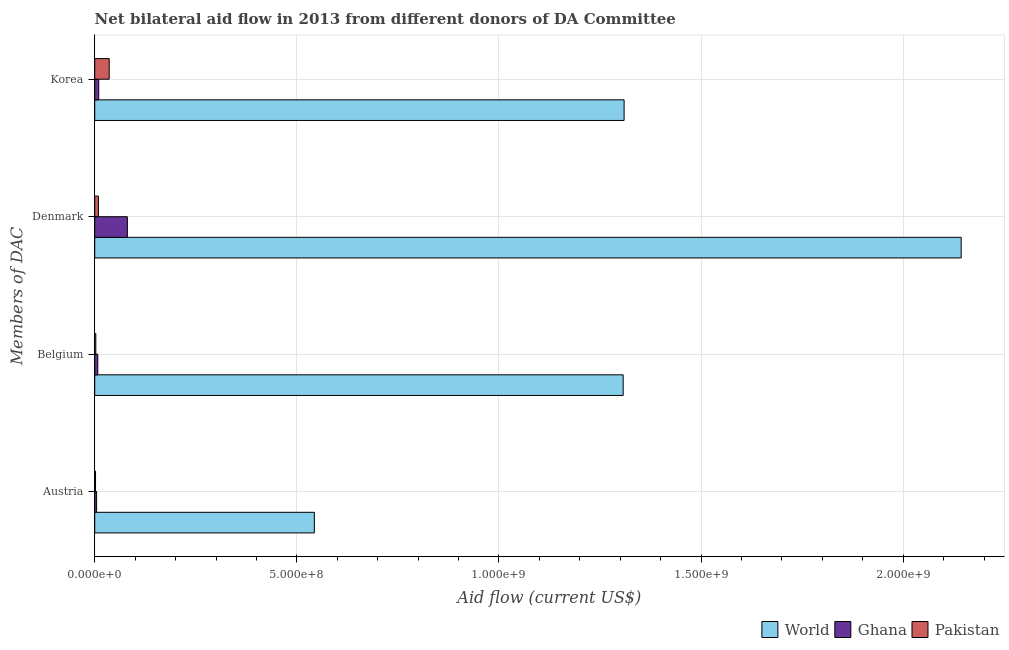Are the number of bars per tick equal to the number of legend labels?
Make the answer very short. Yes. Are the number of bars on each tick of the Y-axis equal?
Keep it short and to the point. Yes. How many bars are there on the 1st tick from the top?
Give a very brief answer. 3. What is the label of the 2nd group of bars from the top?
Your answer should be very brief. Denmark. What is the amount of aid given by belgium in Ghana?
Offer a very short reply. 7.56e+06. Across all countries, what is the maximum amount of aid given by denmark?
Offer a very short reply. 2.14e+09. Across all countries, what is the minimum amount of aid given by austria?
Offer a very short reply. 1.99e+06. What is the total amount of aid given by austria in the graph?
Provide a short and direct response. 5.50e+08. What is the difference between the amount of aid given by austria in Pakistan and that in World?
Offer a very short reply. -5.41e+08. What is the difference between the amount of aid given by belgium in World and the amount of aid given by korea in Pakistan?
Ensure brevity in your answer.  1.27e+09. What is the average amount of aid given by austria per country?
Your answer should be very brief. 1.83e+08. What is the difference between the amount of aid given by korea and amount of aid given by belgium in Ghana?
Ensure brevity in your answer.  2.29e+06. In how many countries, is the amount of aid given by austria greater than 1200000000 US$?
Make the answer very short. 0. What is the ratio of the amount of aid given by korea in World to that in Pakistan?
Offer a very short reply. 36.53. What is the difference between the highest and the second highest amount of aid given by belgium?
Ensure brevity in your answer.  1.30e+09. What is the difference between the highest and the lowest amount of aid given by denmark?
Give a very brief answer. 2.13e+09. Is it the case that in every country, the sum of the amount of aid given by austria and amount of aid given by belgium is greater than the amount of aid given by denmark?
Give a very brief answer. No. How many countries are there in the graph?
Provide a short and direct response. 3. Does the graph contain grids?
Offer a very short reply. Yes. Where does the legend appear in the graph?
Offer a very short reply. Bottom right. What is the title of the graph?
Make the answer very short. Net bilateral aid flow in 2013 from different donors of DA Committee. What is the label or title of the Y-axis?
Give a very brief answer. Members of DAC. What is the Aid flow (current US$) of World in Austria?
Your answer should be very brief. 5.43e+08. What is the Aid flow (current US$) in Ghana in Austria?
Give a very brief answer. 4.59e+06. What is the Aid flow (current US$) of Pakistan in Austria?
Provide a short and direct response. 1.99e+06. What is the Aid flow (current US$) of World in Belgium?
Offer a terse response. 1.31e+09. What is the Aid flow (current US$) of Ghana in Belgium?
Offer a terse response. 7.56e+06. What is the Aid flow (current US$) of Pakistan in Belgium?
Your answer should be compact. 2.69e+06. What is the Aid flow (current US$) of World in Denmark?
Ensure brevity in your answer.  2.14e+09. What is the Aid flow (current US$) of Ghana in Denmark?
Offer a very short reply. 8.07e+07. What is the Aid flow (current US$) of Pakistan in Denmark?
Provide a succinct answer. 9.11e+06. What is the Aid flow (current US$) of World in Korea?
Offer a very short reply. 1.31e+09. What is the Aid flow (current US$) of Ghana in Korea?
Provide a short and direct response. 9.85e+06. What is the Aid flow (current US$) in Pakistan in Korea?
Give a very brief answer. 3.58e+07. Across all Members of DAC, what is the maximum Aid flow (current US$) of World?
Provide a succinct answer. 2.14e+09. Across all Members of DAC, what is the maximum Aid flow (current US$) of Ghana?
Keep it short and to the point. 8.07e+07. Across all Members of DAC, what is the maximum Aid flow (current US$) in Pakistan?
Give a very brief answer. 3.58e+07. Across all Members of DAC, what is the minimum Aid flow (current US$) in World?
Make the answer very short. 5.43e+08. Across all Members of DAC, what is the minimum Aid flow (current US$) in Ghana?
Provide a short and direct response. 4.59e+06. Across all Members of DAC, what is the minimum Aid flow (current US$) in Pakistan?
Ensure brevity in your answer.  1.99e+06. What is the total Aid flow (current US$) of World in the graph?
Give a very brief answer. 5.30e+09. What is the total Aid flow (current US$) of Ghana in the graph?
Keep it short and to the point. 1.03e+08. What is the total Aid flow (current US$) of Pakistan in the graph?
Make the answer very short. 4.96e+07. What is the difference between the Aid flow (current US$) of World in Austria and that in Belgium?
Make the answer very short. -7.64e+08. What is the difference between the Aid flow (current US$) of Ghana in Austria and that in Belgium?
Offer a terse response. -2.97e+06. What is the difference between the Aid flow (current US$) in Pakistan in Austria and that in Belgium?
Provide a short and direct response. -7.00e+05. What is the difference between the Aid flow (current US$) in World in Austria and that in Denmark?
Offer a very short reply. -1.60e+09. What is the difference between the Aid flow (current US$) of Ghana in Austria and that in Denmark?
Make the answer very short. -7.61e+07. What is the difference between the Aid flow (current US$) in Pakistan in Austria and that in Denmark?
Make the answer very short. -7.12e+06. What is the difference between the Aid flow (current US$) of World in Austria and that in Korea?
Your answer should be compact. -7.66e+08. What is the difference between the Aid flow (current US$) in Ghana in Austria and that in Korea?
Offer a very short reply. -5.26e+06. What is the difference between the Aid flow (current US$) of Pakistan in Austria and that in Korea?
Offer a very short reply. -3.39e+07. What is the difference between the Aid flow (current US$) in World in Belgium and that in Denmark?
Provide a short and direct response. -8.36e+08. What is the difference between the Aid flow (current US$) in Ghana in Belgium and that in Denmark?
Make the answer very short. -7.32e+07. What is the difference between the Aid flow (current US$) of Pakistan in Belgium and that in Denmark?
Provide a succinct answer. -6.42e+06. What is the difference between the Aid flow (current US$) in World in Belgium and that in Korea?
Provide a succinct answer. -2.29e+06. What is the difference between the Aid flow (current US$) in Ghana in Belgium and that in Korea?
Offer a very short reply. -2.29e+06. What is the difference between the Aid flow (current US$) of Pakistan in Belgium and that in Korea?
Ensure brevity in your answer.  -3.32e+07. What is the difference between the Aid flow (current US$) of World in Denmark and that in Korea?
Your answer should be very brief. 8.34e+08. What is the difference between the Aid flow (current US$) in Ghana in Denmark and that in Korea?
Your answer should be compact. 7.09e+07. What is the difference between the Aid flow (current US$) in Pakistan in Denmark and that in Korea?
Your answer should be compact. -2.67e+07. What is the difference between the Aid flow (current US$) of World in Austria and the Aid flow (current US$) of Ghana in Belgium?
Give a very brief answer. 5.36e+08. What is the difference between the Aid flow (current US$) in World in Austria and the Aid flow (current US$) in Pakistan in Belgium?
Keep it short and to the point. 5.41e+08. What is the difference between the Aid flow (current US$) in Ghana in Austria and the Aid flow (current US$) in Pakistan in Belgium?
Make the answer very short. 1.90e+06. What is the difference between the Aid flow (current US$) of World in Austria and the Aid flow (current US$) of Ghana in Denmark?
Your response must be concise. 4.63e+08. What is the difference between the Aid flow (current US$) of World in Austria and the Aid flow (current US$) of Pakistan in Denmark?
Keep it short and to the point. 5.34e+08. What is the difference between the Aid flow (current US$) of Ghana in Austria and the Aid flow (current US$) of Pakistan in Denmark?
Your answer should be very brief. -4.52e+06. What is the difference between the Aid flow (current US$) in World in Austria and the Aid flow (current US$) in Ghana in Korea?
Provide a short and direct response. 5.33e+08. What is the difference between the Aid flow (current US$) of World in Austria and the Aid flow (current US$) of Pakistan in Korea?
Provide a succinct answer. 5.07e+08. What is the difference between the Aid flow (current US$) in Ghana in Austria and the Aid flow (current US$) in Pakistan in Korea?
Your response must be concise. -3.13e+07. What is the difference between the Aid flow (current US$) in World in Belgium and the Aid flow (current US$) in Ghana in Denmark?
Provide a short and direct response. 1.23e+09. What is the difference between the Aid flow (current US$) of World in Belgium and the Aid flow (current US$) of Pakistan in Denmark?
Your answer should be compact. 1.30e+09. What is the difference between the Aid flow (current US$) in Ghana in Belgium and the Aid flow (current US$) in Pakistan in Denmark?
Your answer should be very brief. -1.55e+06. What is the difference between the Aid flow (current US$) of World in Belgium and the Aid flow (current US$) of Ghana in Korea?
Make the answer very short. 1.30e+09. What is the difference between the Aid flow (current US$) of World in Belgium and the Aid flow (current US$) of Pakistan in Korea?
Offer a very short reply. 1.27e+09. What is the difference between the Aid flow (current US$) in Ghana in Belgium and the Aid flow (current US$) in Pakistan in Korea?
Keep it short and to the point. -2.83e+07. What is the difference between the Aid flow (current US$) in World in Denmark and the Aid flow (current US$) in Ghana in Korea?
Your answer should be very brief. 2.13e+09. What is the difference between the Aid flow (current US$) in World in Denmark and the Aid flow (current US$) in Pakistan in Korea?
Your response must be concise. 2.11e+09. What is the difference between the Aid flow (current US$) of Ghana in Denmark and the Aid flow (current US$) of Pakistan in Korea?
Provide a short and direct response. 4.49e+07. What is the average Aid flow (current US$) of World per Members of DAC?
Your response must be concise. 1.33e+09. What is the average Aid flow (current US$) of Ghana per Members of DAC?
Give a very brief answer. 2.57e+07. What is the average Aid flow (current US$) of Pakistan per Members of DAC?
Keep it short and to the point. 1.24e+07. What is the difference between the Aid flow (current US$) in World and Aid flow (current US$) in Ghana in Austria?
Offer a terse response. 5.39e+08. What is the difference between the Aid flow (current US$) in World and Aid flow (current US$) in Pakistan in Austria?
Offer a terse response. 5.41e+08. What is the difference between the Aid flow (current US$) of Ghana and Aid flow (current US$) of Pakistan in Austria?
Offer a terse response. 2.60e+06. What is the difference between the Aid flow (current US$) of World and Aid flow (current US$) of Ghana in Belgium?
Your answer should be compact. 1.30e+09. What is the difference between the Aid flow (current US$) of World and Aid flow (current US$) of Pakistan in Belgium?
Your response must be concise. 1.30e+09. What is the difference between the Aid flow (current US$) in Ghana and Aid flow (current US$) in Pakistan in Belgium?
Offer a terse response. 4.87e+06. What is the difference between the Aid flow (current US$) in World and Aid flow (current US$) in Ghana in Denmark?
Your answer should be compact. 2.06e+09. What is the difference between the Aid flow (current US$) in World and Aid flow (current US$) in Pakistan in Denmark?
Keep it short and to the point. 2.13e+09. What is the difference between the Aid flow (current US$) of Ghana and Aid flow (current US$) of Pakistan in Denmark?
Offer a very short reply. 7.16e+07. What is the difference between the Aid flow (current US$) of World and Aid flow (current US$) of Ghana in Korea?
Provide a short and direct response. 1.30e+09. What is the difference between the Aid flow (current US$) in World and Aid flow (current US$) in Pakistan in Korea?
Ensure brevity in your answer.  1.27e+09. What is the difference between the Aid flow (current US$) in Ghana and Aid flow (current US$) in Pakistan in Korea?
Keep it short and to the point. -2.60e+07. What is the ratio of the Aid flow (current US$) of World in Austria to that in Belgium?
Offer a very short reply. 0.42. What is the ratio of the Aid flow (current US$) of Ghana in Austria to that in Belgium?
Your response must be concise. 0.61. What is the ratio of the Aid flow (current US$) in Pakistan in Austria to that in Belgium?
Your answer should be compact. 0.74. What is the ratio of the Aid flow (current US$) of World in Austria to that in Denmark?
Your answer should be very brief. 0.25. What is the ratio of the Aid flow (current US$) in Ghana in Austria to that in Denmark?
Ensure brevity in your answer.  0.06. What is the ratio of the Aid flow (current US$) of Pakistan in Austria to that in Denmark?
Offer a very short reply. 0.22. What is the ratio of the Aid flow (current US$) of World in Austria to that in Korea?
Your answer should be compact. 0.41. What is the ratio of the Aid flow (current US$) of Ghana in Austria to that in Korea?
Keep it short and to the point. 0.47. What is the ratio of the Aid flow (current US$) of Pakistan in Austria to that in Korea?
Offer a very short reply. 0.06. What is the ratio of the Aid flow (current US$) of World in Belgium to that in Denmark?
Offer a very short reply. 0.61. What is the ratio of the Aid flow (current US$) in Ghana in Belgium to that in Denmark?
Offer a terse response. 0.09. What is the ratio of the Aid flow (current US$) of Pakistan in Belgium to that in Denmark?
Provide a succinct answer. 0.3. What is the ratio of the Aid flow (current US$) of World in Belgium to that in Korea?
Provide a short and direct response. 1. What is the ratio of the Aid flow (current US$) of Ghana in Belgium to that in Korea?
Give a very brief answer. 0.77. What is the ratio of the Aid flow (current US$) in Pakistan in Belgium to that in Korea?
Give a very brief answer. 0.07. What is the ratio of the Aid flow (current US$) in World in Denmark to that in Korea?
Your answer should be very brief. 1.64. What is the ratio of the Aid flow (current US$) of Ghana in Denmark to that in Korea?
Give a very brief answer. 8.19. What is the ratio of the Aid flow (current US$) of Pakistan in Denmark to that in Korea?
Keep it short and to the point. 0.25. What is the difference between the highest and the second highest Aid flow (current US$) in World?
Offer a terse response. 8.34e+08. What is the difference between the highest and the second highest Aid flow (current US$) of Ghana?
Give a very brief answer. 7.09e+07. What is the difference between the highest and the second highest Aid flow (current US$) in Pakistan?
Keep it short and to the point. 2.67e+07. What is the difference between the highest and the lowest Aid flow (current US$) of World?
Your response must be concise. 1.60e+09. What is the difference between the highest and the lowest Aid flow (current US$) in Ghana?
Offer a very short reply. 7.61e+07. What is the difference between the highest and the lowest Aid flow (current US$) in Pakistan?
Your response must be concise. 3.39e+07. 